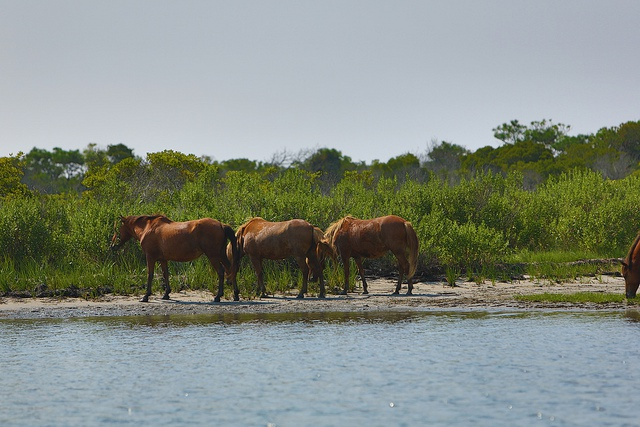Describe the objects in this image and their specific colors. I can see horse in darkgray, black, maroon, olive, and brown tones, horse in darkgray, black, maroon, and gray tones, horse in darkgray, black, gray, and maroon tones, and horse in darkgray, black, maroon, olive, and brown tones in this image. 